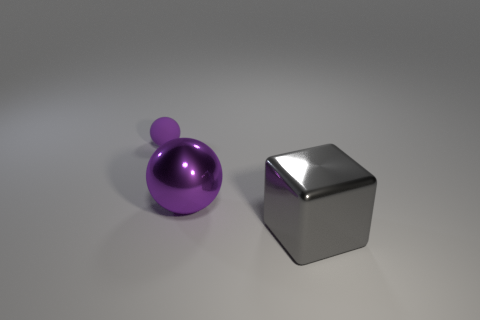Does the tiny purple thing have the same material as the large thing that is behind the gray shiny object?
Make the answer very short. No. There is a block to the right of the purple thing that is behind the purple thing that is in front of the purple matte thing; what is its color?
Provide a succinct answer. Gray. Are there any other things that have the same shape as the large purple shiny object?
Your answer should be compact. Yes. Is the number of purple metallic objects greater than the number of big metal objects?
Your answer should be compact. No. What number of objects are in front of the rubber thing and behind the large gray metallic block?
Offer a very short reply. 1. What number of tiny purple objects are on the left side of the purple thing that is in front of the small purple ball?
Make the answer very short. 1. Is the size of the metal cube that is in front of the tiny purple rubber sphere the same as the purple sphere that is in front of the tiny rubber object?
Your response must be concise. Yes. How many green metallic cylinders are there?
Provide a short and direct response. 0. How many spheres have the same material as the gray block?
Keep it short and to the point. 1. Is the number of rubber balls to the left of the small purple ball the same as the number of tiny blue rubber balls?
Provide a succinct answer. Yes. 